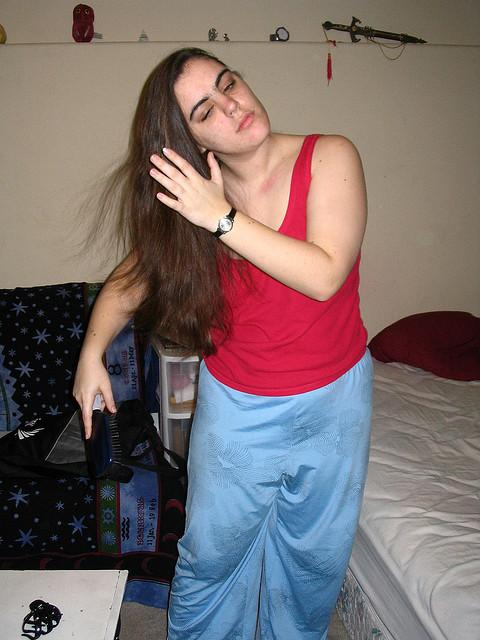What item hanging on the wall would help most on a battlefield? sword 